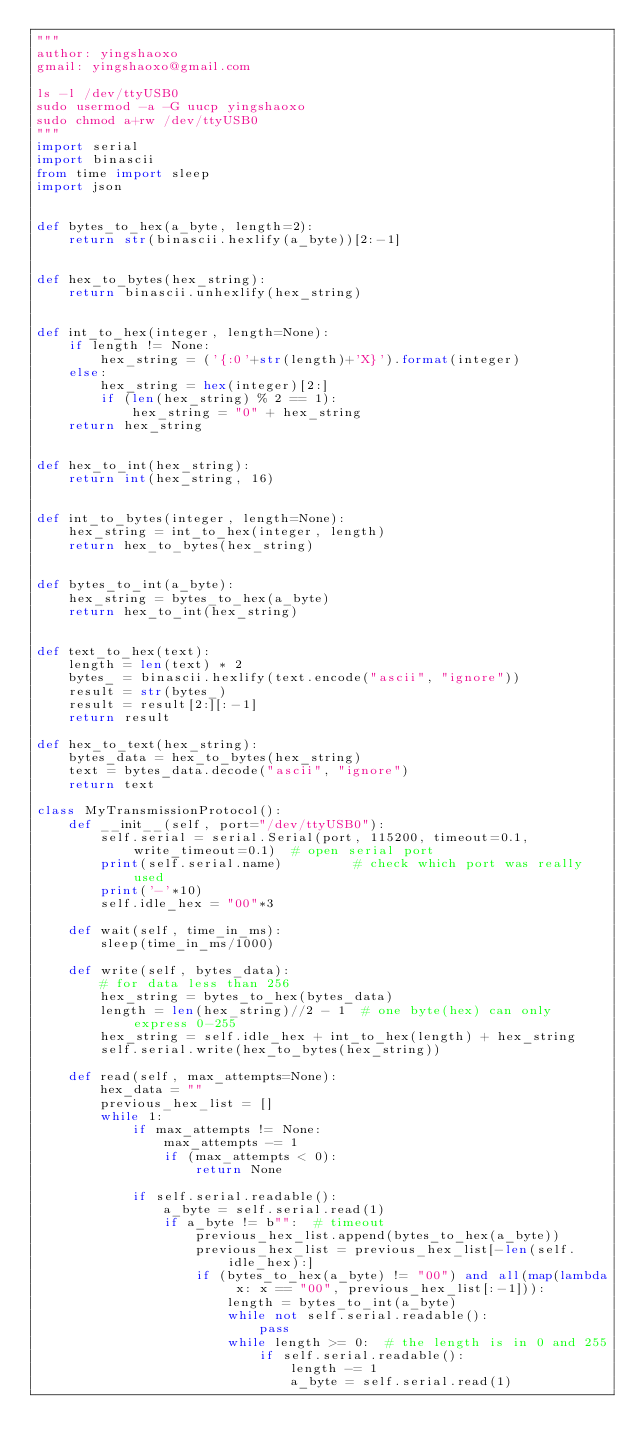<code> <loc_0><loc_0><loc_500><loc_500><_Python_>"""
author: yingshaoxo
gmail: yingshaoxo@gmail.com

ls -l /dev/ttyUSB0
sudo usermod -a -G uucp yingshaoxo
sudo chmod a+rw /dev/ttyUSB0
"""
import serial
import binascii
from time import sleep
import json


def bytes_to_hex(a_byte, length=2):
    return str(binascii.hexlify(a_byte))[2:-1]


def hex_to_bytes(hex_string):
    return binascii.unhexlify(hex_string)


def int_to_hex(integer, length=None):
    if length != None:
        hex_string = ('{:0'+str(length)+'X}').format(integer)
    else:
        hex_string = hex(integer)[2:]
        if (len(hex_string) % 2 == 1):
            hex_string = "0" + hex_string
    return hex_string


def hex_to_int(hex_string):
    return int(hex_string, 16)


def int_to_bytes(integer, length=None):
    hex_string = int_to_hex(integer, length)
    return hex_to_bytes(hex_string)


def bytes_to_int(a_byte):
    hex_string = bytes_to_hex(a_byte)
    return hex_to_int(hex_string)


def text_to_hex(text):
    length = len(text) * 2
    bytes_ = binascii.hexlify(text.encode("ascii", "ignore"))
    result = str(bytes_)
    result = result[2:][:-1]
    return result

def hex_to_text(hex_string):
    bytes_data = hex_to_bytes(hex_string)
    text = bytes_data.decode("ascii", "ignore")
    return text

class MyTransmissionProtocol():
    def __init__(self, port="/dev/ttyUSB0"):
        self.serial = serial.Serial(port, 115200, timeout=0.1, write_timeout=0.1)  # open serial port
        print(self.serial.name)         # check which port was really used
        print('-'*10)
        self.idle_hex = "00"*3

    def wait(self, time_in_ms):
        sleep(time_in_ms/1000)

    def write(self, bytes_data):
        # for data less than 256
        hex_string = bytes_to_hex(bytes_data)
        length = len(hex_string)//2 - 1  # one byte(hex) can only express 0-255
        hex_string = self.idle_hex + int_to_hex(length) + hex_string
        self.serial.write(hex_to_bytes(hex_string))

    def read(self, max_attempts=None):
        hex_data = ""
        previous_hex_list = []
        while 1:
            if max_attempts != None:
                max_attempts -= 1
                if (max_attempts < 0):
                    return None

            if self.serial.readable():
                a_byte = self.serial.read(1)
                if a_byte != b"":  # timeout
                    previous_hex_list.append(bytes_to_hex(a_byte))
                    previous_hex_list = previous_hex_list[-len(self.idle_hex):]
                    if (bytes_to_hex(a_byte) != "00") and all(map(lambda x: x == "00", previous_hex_list[:-1])):
                        length = bytes_to_int(a_byte)
                        while not self.serial.readable():
                            pass
                        while length >= 0:  # the length is in 0 and 255
                            if self.serial.readable():
                                length -= 1
                                a_byte = self.serial.read(1)</code> 